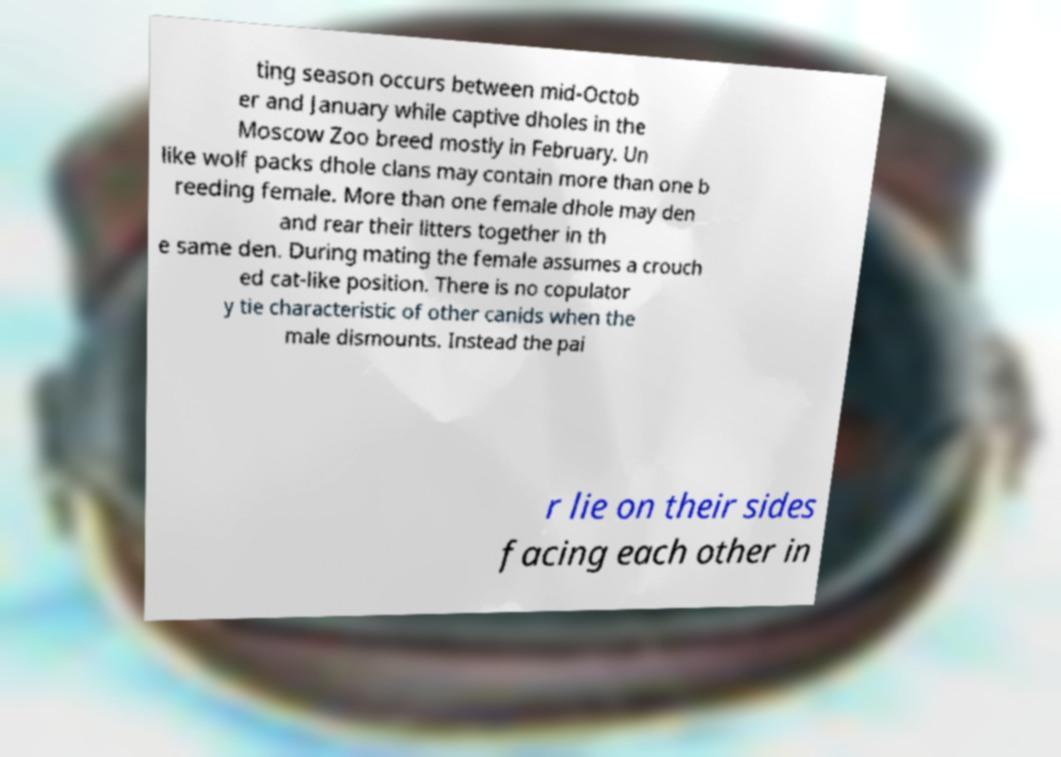I need the written content from this picture converted into text. Can you do that? ting season occurs between mid-Octob er and January while captive dholes in the Moscow Zoo breed mostly in February. Un like wolf packs dhole clans may contain more than one b reeding female. More than one female dhole may den and rear their litters together in th e same den. During mating the female assumes a crouch ed cat-like position. There is no copulator y tie characteristic of other canids when the male dismounts. Instead the pai r lie on their sides facing each other in 